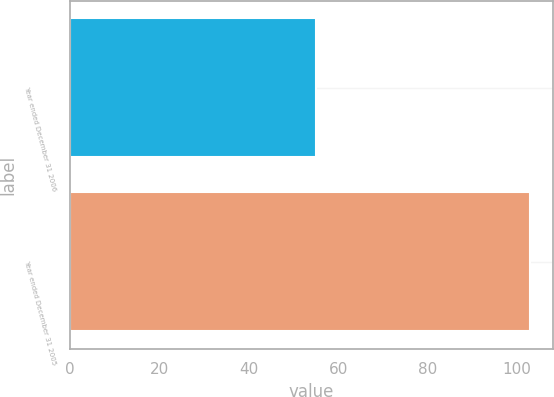<chart> <loc_0><loc_0><loc_500><loc_500><bar_chart><fcel>Year ended December 31 2006<fcel>Year ended December 31 2005<nl><fcel>55<fcel>103<nl></chart> 